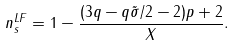Convert formula to latex. <formula><loc_0><loc_0><loc_500><loc_500>n _ { s } ^ { L F } = 1 - \frac { ( 3 q - q \tilde { \sigma } / 2 - 2 ) p + 2 } { X } .</formula> 